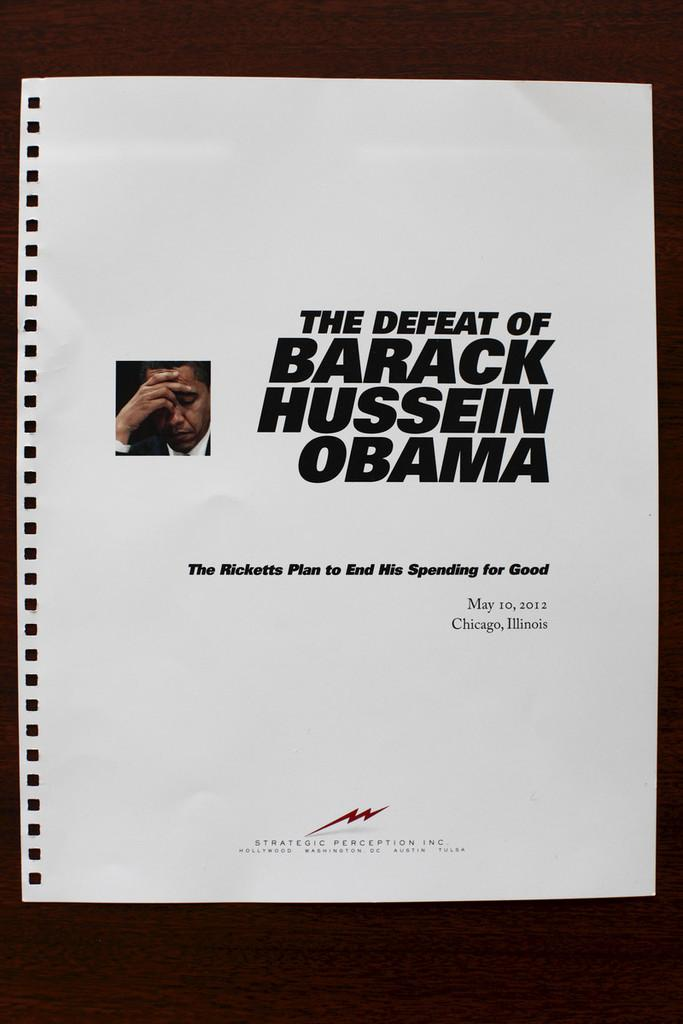What is the main subject of the image? There is a photo in the image. What else is present in the image besides the photo? There is text on a paper in the image. Where are the photo and text on the paper located? The photo and text on the paper are placed on a surface. How many horses can be seen in the image? There are no horses present in the image. What is the reason for the text on the paper in the image? The image does not provide any information about the reason for the text on the paper. 